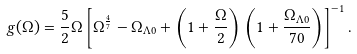<formula> <loc_0><loc_0><loc_500><loc_500>g ( \Omega ) = \frac { 5 } { 2 } \Omega \left [ \Omega ^ { \frac { 4 } { 7 } } - \Omega _ { \Lambda 0 } + \left ( 1 + \frac { \Omega } { 2 } \right ) \left ( 1 + \frac { \Omega _ { \Lambda 0 } } { 7 0 } \right ) \right ] ^ { - 1 } .</formula> 